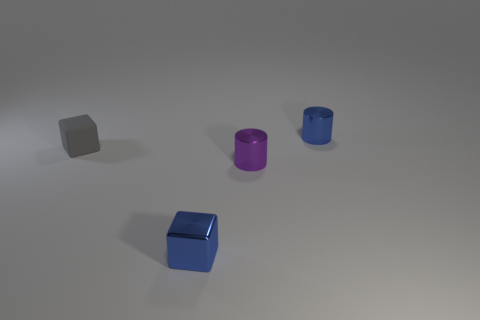Is there any other thing that is made of the same material as the tiny gray thing?
Make the answer very short. No. Is the number of metal cylinders greater than the number of small yellow objects?
Provide a short and direct response. Yes. What shape is the gray thing?
Keep it short and to the point. Cube. Are there more tiny metallic cylinders behind the gray rubber block than brown balls?
Provide a succinct answer. Yes. What is the shape of the blue metallic object in front of the metal cylinder that is behind the thing on the left side of the blue metallic cube?
Your answer should be very brief. Cube. There is a small thing that is left of the tiny purple thing and behind the purple metal cylinder; what shape is it?
Your answer should be very brief. Cube. There is a metal block; does it have the same color as the cylinder that is behind the gray rubber block?
Provide a succinct answer. Yes. The tiny shiny cylinder in front of the small cube that is to the left of the metal cube that is on the right side of the gray rubber object is what color?
Ensure brevity in your answer.  Purple. What color is the other object that is the same shape as the small gray rubber thing?
Keep it short and to the point. Blue. Is the number of gray matte objects that are in front of the purple cylinder the same as the number of tiny purple cylinders?
Ensure brevity in your answer.  No. 